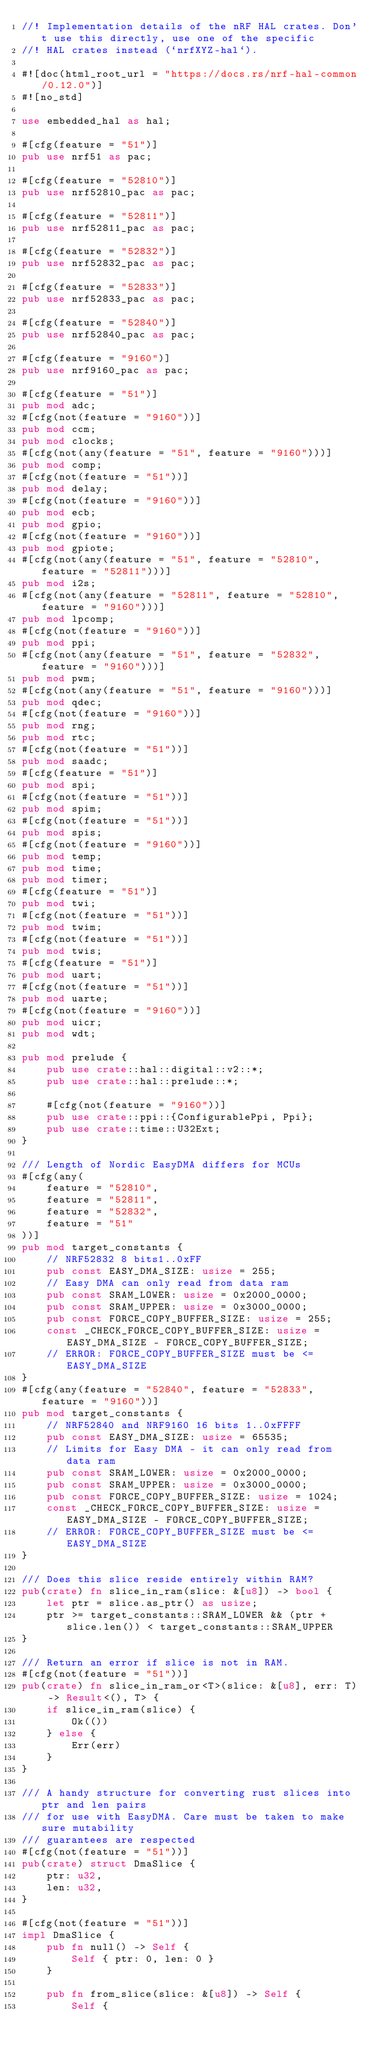Convert code to text. <code><loc_0><loc_0><loc_500><loc_500><_Rust_>//! Implementation details of the nRF HAL crates. Don't use this directly, use one of the specific
//! HAL crates instead (`nrfXYZ-hal`).

#![doc(html_root_url = "https://docs.rs/nrf-hal-common/0.12.0")]
#![no_std]

use embedded_hal as hal;

#[cfg(feature = "51")]
pub use nrf51 as pac;

#[cfg(feature = "52810")]
pub use nrf52810_pac as pac;

#[cfg(feature = "52811")]
pub use nrf52811_pac as pac;

#[cfg(feature = "52832")]
pub use nrf52832_pac as pac;

#[cfg(feature = "52833")]
pub use nrf52833_pac as pac;

#[cfg(feature = "52840")]
pub use nrf52840_pac as pac;

#[cfg(feature = "9160")]
pub use nrf9160_pac as pac;

#[cfg(feature = "51")]
pub mod adc;
#[cfg(not(feature = "9160"))]
pub mod ccm;
pub mod clocks;
#[cfg(not(any(feature = "51", feature = "9160")))]
pub mod comp;
#[cfg(not(feature = "51"))]
pub mod delay;
#[cfg(not(feature = "9160"))]
pub mod ecb;
pub mod gpio;
#[cfg(not(feature = "9160"))]
pub mod gpiote;
#[cfg(not(any(feature = "51", feature = "52810", feature = "52811")))]
pub mod i2s;
#[cfg(not(any(feature = "52811", feature = "52810", feature = "9160")))]
pub mod lpcomp;
#[cfg(not(feature = "9160"))]
pub mod ppi;
#[cfg(not(any(feature = "51", feature = "52832", feature = "9160")))]
pub mod pwm;
#[cfg(not(any(feature = "51", feature = "9160")))]
pub mod qdec;
#[cfg(not(feature = "9160"))]
pub mod rng;
pub mod rtc;
#[cfg(not(feature = "51"))]
pub mod saadc;
#[cfg(feature = "51")]
pub mod spi;
#[cfg(not(feature = "51"))]
pub mod spim;
#[cfg(not(feature = "51"))]
pub mod spis;
#[cfg(not(feature = "9160"))]
pub mod temp;
pub mod time;
pub mod timer;
#[cfg(feature = "51")]
pub mod twi;
#[cfg(not(feature = "51"))]
pub mod twim;
#[cfg(not(feature = "51"))]
pub mod twis;
#[cfg(feature = "51")]
pub mod uart;
#[cfg(not(feature = "51"))]
pub mod uarte;
#[cfg(not(feature = "9160"))]
pub mod uicr;
pub mod wdt;

pub mod prelude {
    pub use crate::hal::digital::v2::*;
    pub use crate::hal::prelude::*;

    #[cfg(not(feature = "9160"))]
    pub use crate::ppi::{ConfigurablePpi, Ppi};
    pub use crate::time::U32Ext;
}

/// Length of Nordic EasyDMA differs for MCUs
#[cfg(any(
    feature = "52810",
    feature = "52811",
    feature = "52832",
    feature = "51"
))]
pub mod target_constants {
    // NRF52832 8 bits1..0xFF
    pub const EASY_DMA_SIZE: usize = 255;
    // Easy DMA can only read from data ram
    pub const SRAM_LOWER: usize = 0x2000_0000;
    pub const SRAM_UPPER: usize = 0x3000_0000;
    pub const FORCE_COPY_BUFFER_SIZE: usize = 255;
    const _CHECK_FORCE_COPY_BUFFER_SIZE: usize = EASY_DMA_SIZE - FORCE_COPY_BUFFER_SIZE;
    // ERROR: FORCE_COPY_BUFFER_SIZE must be <= EASY_DMA_SIZE
}
#[cfg(any(feature = "52840", feature = "52833", feature = "9160"))]
pub mod target_constants {
    // NRF52840 and NRF9160 16 bits 1..0xFFFF
    pub const EASY_DMA_SIZE: usize = 65535;
    // Limits for Easy DMA - it can only read from data ram
    pub const SRAM_LOWER: usize = 0x2000_0000;
    pub const SRAM_UPPER: usize = 0x3000_0000;
    pub const FORCE_COPY_BUFFER_SIZE: usize = 1024;
    const _CHECK_FORCE_COPY_BUFFER_SIZE: usize = EASY_DMA_SIZE - FORCE_COPY_BUFFER_SIZE;
    // ERROR: FORCE_COPY_BUFFER_SIZE must be <= EASY_DMA_SIZE
}

/// Does this slice reside entirely within RAM?
pub(crate) fn slice_in_ram(slice: &[u8]) -> bool {
    let ptr = slice.as_ptr() as usize;
    ptr >= target_constants::SRAM_LOWER && (ptr + slice.len()) < target_constants::SRAM_UPPER
}

/// Return an error if slice is not in RAM.
#[cfg(not(feature = "51"))]
pub(crate) fn slice_in_ram_or<T>(slice: &[u8], err: T) -> Result<(), T> {
    if slice_in_ram(slice) {
        Ok(())
    } else {
        Err(err)
    }
}

/// A handy structure for converting rust slices into ptr and len pairs
/// for use with EasyDMA. Care must be taken to make sure mutability
/// guarantees are respected
#[cfg(not(feature = "51"))]
pub(crate) struct DmaSlice {
    ptr: u32,
    len: u32,
}

#[cfg(not(feature = "51"))]
impl DmaSlice {
    pub fn null() -> Self {
        Self { ptr: 0, len: 0 }
    }

    pub fn from_slice(slice: &[u8]) -> Self {
        Self {</code> 